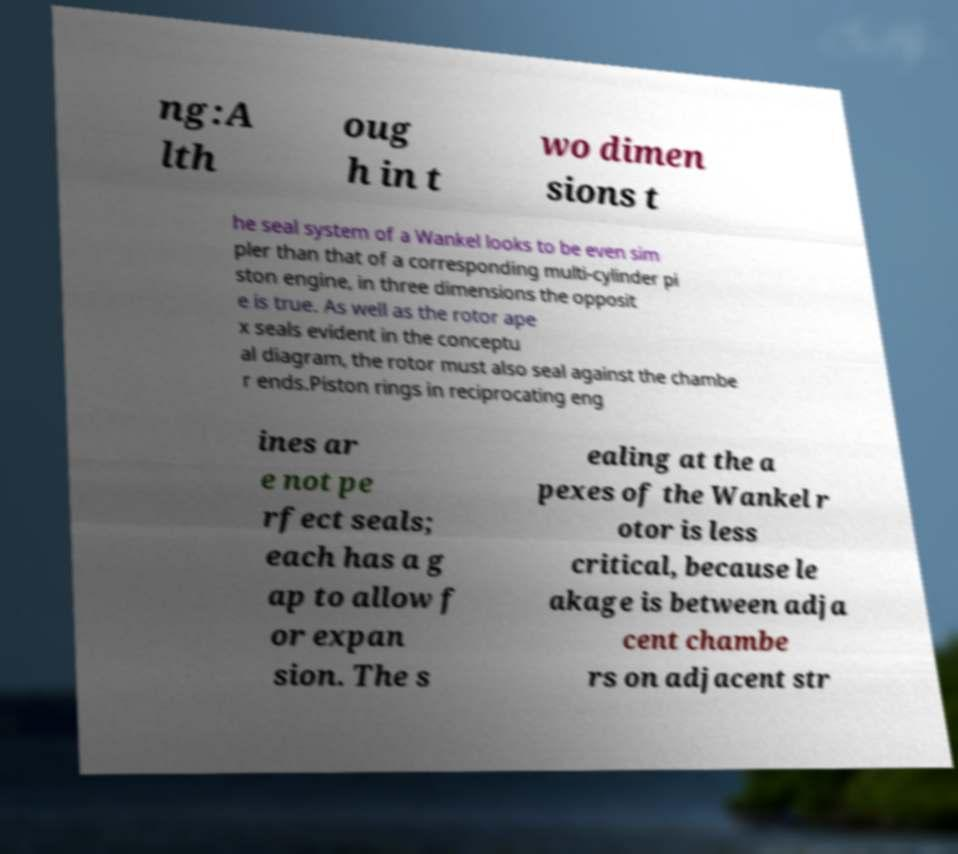Can you accurately transcribe the text from the provided image for me? ng:A lth oug h in t wo dimen sions t he seal system of a Wankel looks to be even sim pler than that of a corresponding multi-cylinder pi ston engine, in three dimensions the opposit e is true. As well as the rotor ape x seals evident in the conceptu al diagram, the rotor must also seal against the chambe r ends.Piston rings in reciprocating eng ines ar e not pe rfect seals; each has a g ap to allow f or expan sion. The s ealing at the a pexes of the Wankel r otor is less critical, because le akage is between adja cent chambe rs on adjacent str 